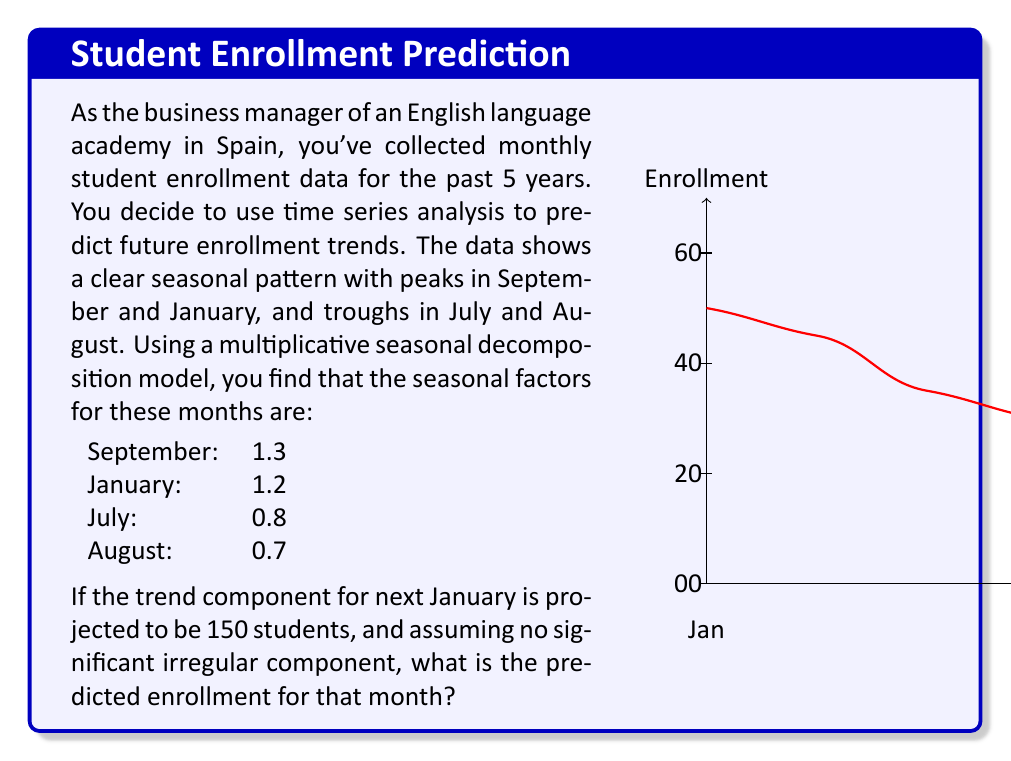Show me your answer to this math problem. To solve this problem, we need to understand the components of a multiplicative time series model and how to use them for prediction. The multiplicative model is given by:

$$Y_t = T_t \times S_t \times I_t$$

Where:
$Y_t$ is the observed value
$T_t$ is the trend component
$S_t$ is the seasonal component
$I_t$ is the irregular component

We're given that:
1. The trend component ($T_t$) for next January is 150 students.
2. The seasonal factor ($S_t$) for January is 1.2.
3. We're assuming no significant irregular component ($I_t \approx 1$).

To predict the enrollment for next January, we multiply these components:

$$Y_t = T_t \times S_t \times I_t$$
$$Y_t = 150 \times 1.2 \times 1$$
$$Y_t = 180$$

Therefore, the predicted enrollment for next January is 180 students.

This method accounts for both the underlying trend in student numbers and the seasonal fluctuations that occur throughout the year. The multiplicative model is particularly useful when the seasonal variation increases as the trend increases, which is often the case in enrollment data.
Answer: 180 students 